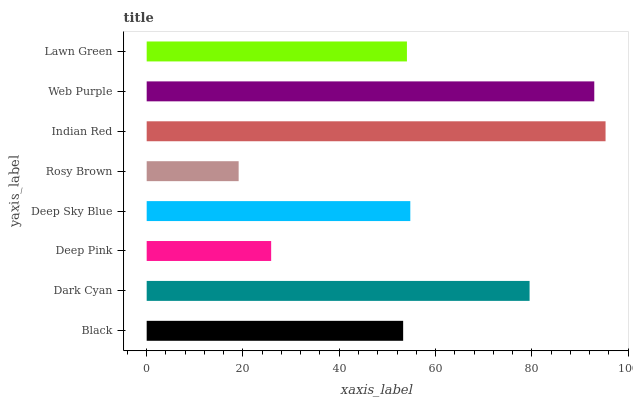Is Rosy Brown the minimum?
Answer yes or no. Yes. Is Indian Red the maximum?
Answer yes or no. Yes. Is Dark Cyan the minimum?
Answer yes or no. No. Is Dark Cyan the maximum?
Answer yes or no. No. Is Dark Cyan greater than Black?
Answer yes or no. Yes. Is Black less than Dark Cyan?
Answer yes or no. Yes. Is Black greater than Dark Cyan?
Answer yes or no. No. Is Dark Cyan less than Black?
Answer yes or no. No. Is Deep Sky Blue the high median?
Answer yes or no. Yes. Is Lawn Green the low median?
Answer yes or no. Yes. Is Deep Pink the high median?
Answer yes or no. No. Is Deep Pink the low median?
Answer yes or no. No. 